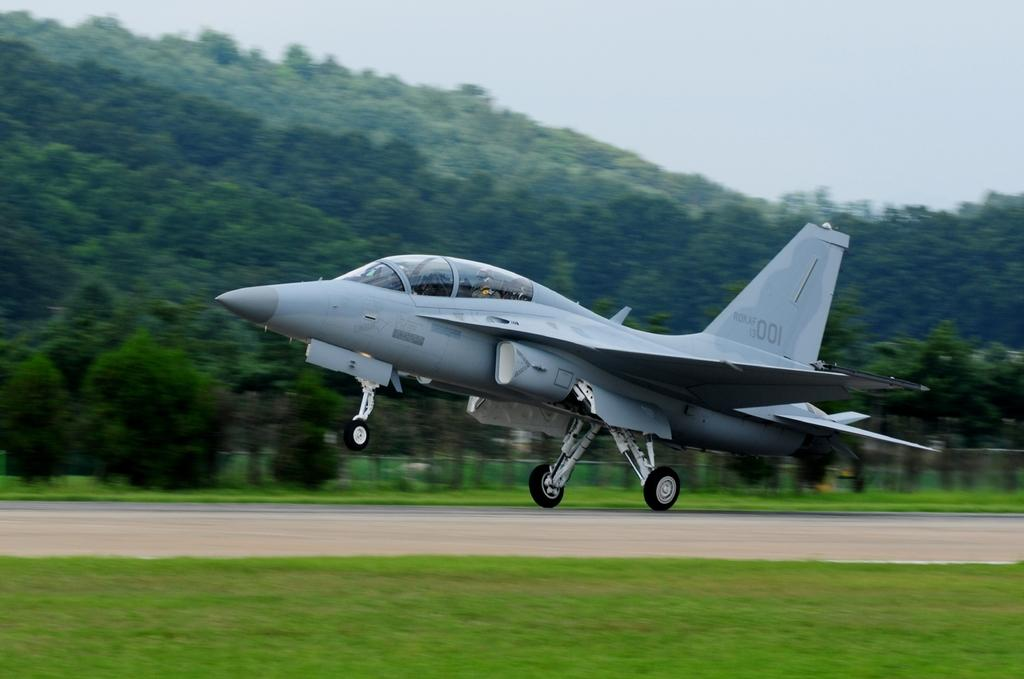Provide a one-sentence caption for the provided image. A small jet can be seen with the numbers 001 fainly on the tail. 